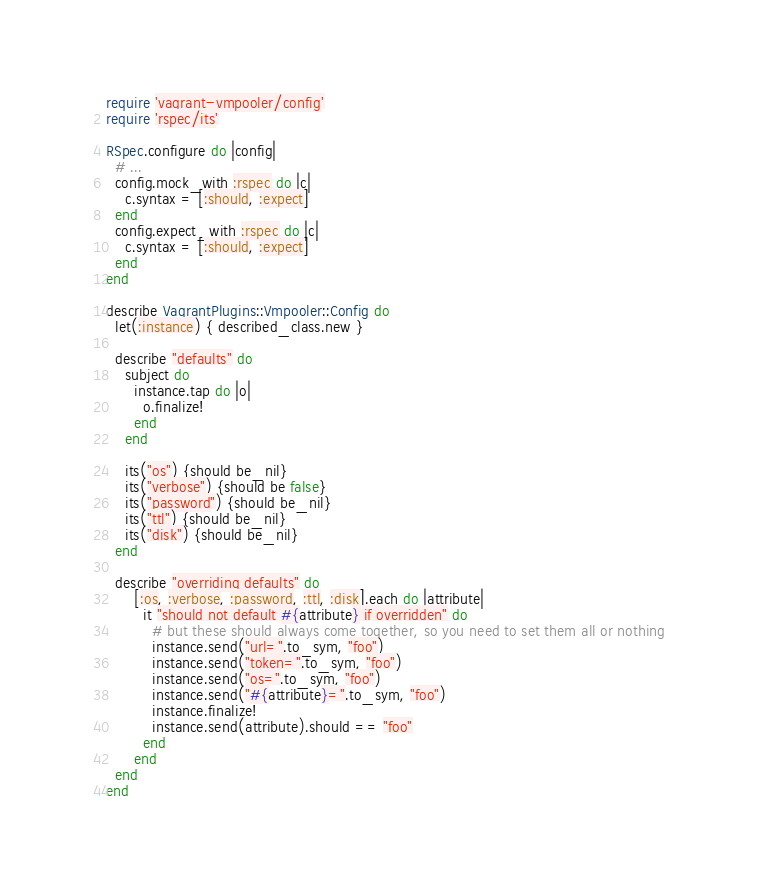<code> <loc_0><loc_0><loc_500><loc_500><_Ruby_>require 'vagrant-vmpooler/config'
require 'rspec/its'

RSpec.configure do |config|
  # ...
  config.mock_with :rspec do |c|
    c.syntax = [:should, :expect]
  end
  config.expect_with :rspec do |c|
    c.syntax = [:should, :expect]
  end
end

describe VagrantPlugins::Vmpooler::Config do
  let(:instance) { described_class.new }

  describe "defaults" do
    subject do
      instance.tap do |o|
        o.finalize!
      end
    end

    its("os") {should be_nil}
    its("verbose") {should be false}
    its("password") {should be_nil}
    its("ttl") {should be_nil}
    its("disk") {should be_nil}
  end

  describe "overriding defaults" do
      [:os, :verbose, :password, :ttl, :disk].each do |attribute|
        it "should not default #{attribute} if overridden" do
          # but these should always come together, so you need to set them all or nothing
          instance.send("url=".to_sym, "foo")
          instance.send("token=".to_sym, "foo")
          instance.send("os=".to_sym, "foo")
          instance.send("#{attribute}=".to_sym, "foo")
          instance.finalize!
          instance.send(attribute).should == "foo"
        end
      end
  end
end
</code> 